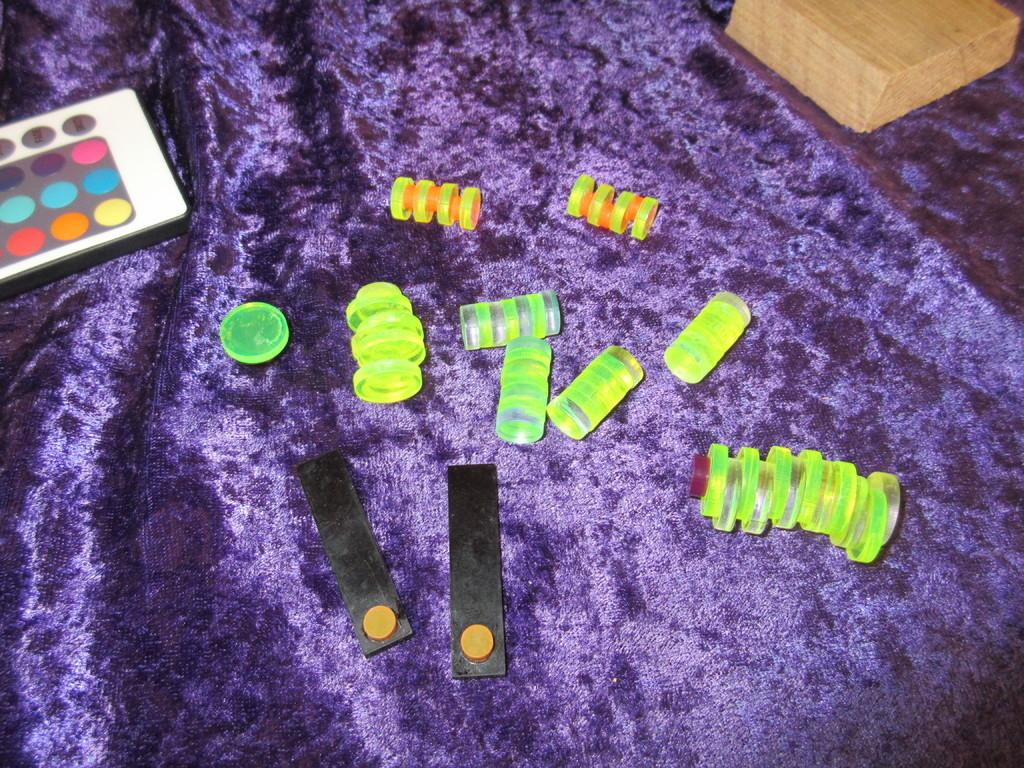What can be seen in the image? There are objects visible in the image. What is the color of the cloth on which the objects are placed? The cloth is purple in color. Can you see a lamp in the image? There is no mention of a lamp in the provided facts, so it cannot be determined if a lamp is present in the image. How many wrens can be seen in the image? There is no mention of wrens in the provided facts, so it cannot be determined if any wrens are present in the image. 